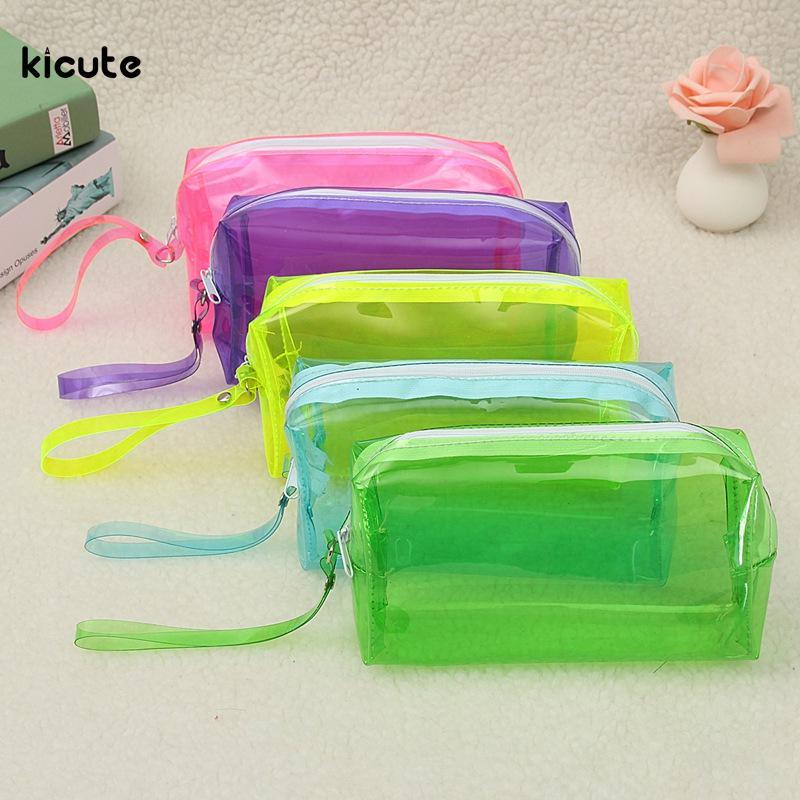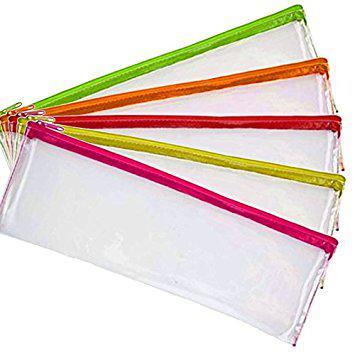The first image is the image on the left, the second image is the image on the right. For the images displayed, is the sentence "There are exactly two pouches in total." factually correct? Answer yes or no. No. The first image is the image on the left, the second image is the image on the right. For the images displayed, is the sentence "There are exactly two translucent pencil pouches." factually correct? Answer yes or no. No. 